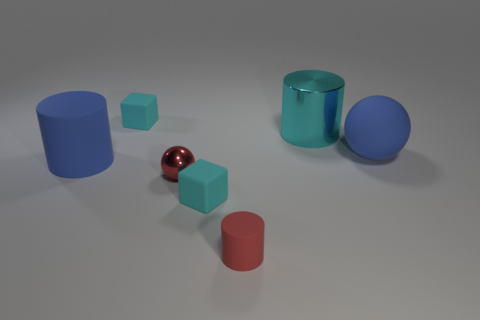Imagine this as a still from an animation, what story could be happening here? This scene could represent a moment of stillness in a larger narrative exploring the themes of scale and perspective. Perhaps in this world, a character is experimenting with a device that could change the size of objects, and we're seeing a pause in their trial-and-error process, contemplating their next move amidst the varying-sized items. 